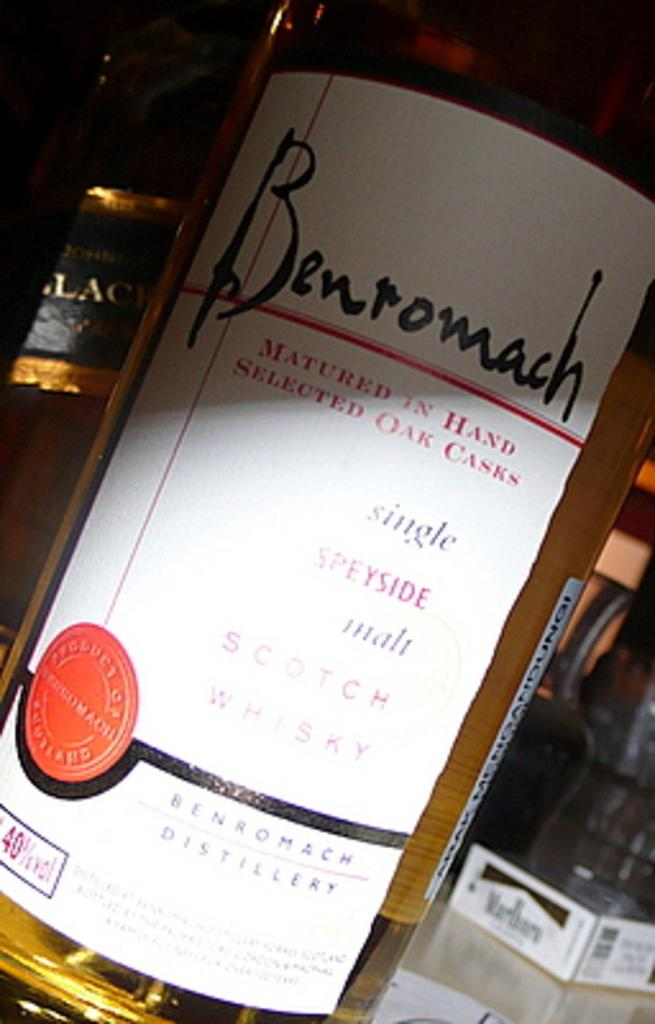<image>
Relay a brief, clear account of the picture shown. A wine label says that it was matured in hand. 